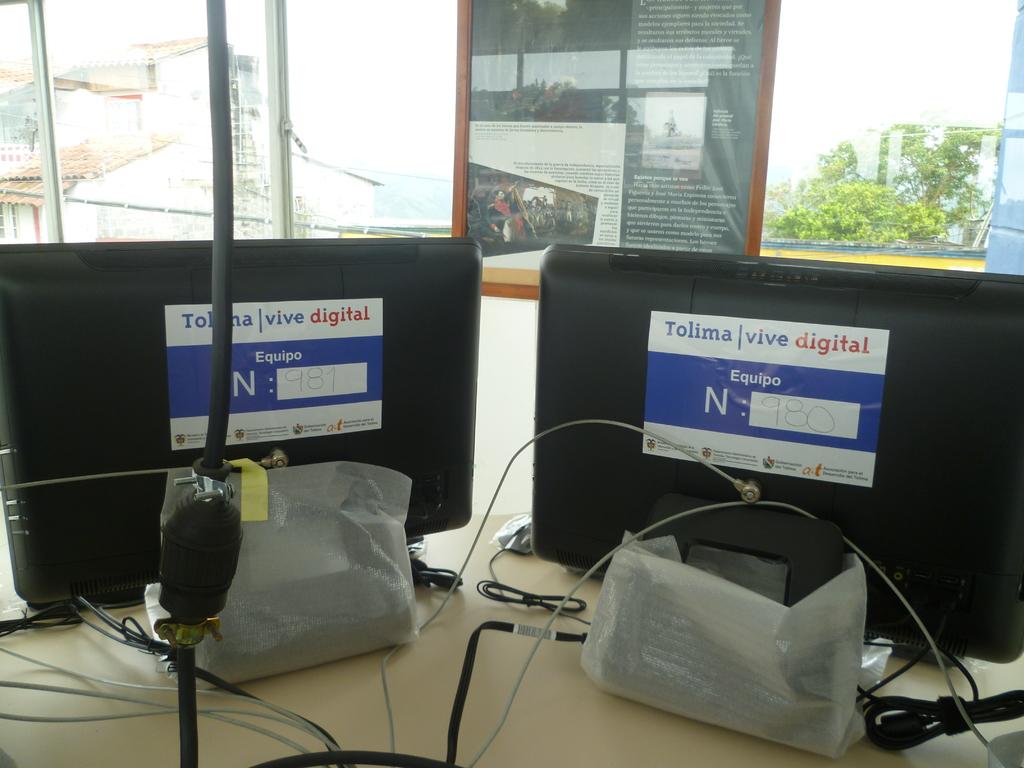What is the word in red?
Provide a short and direct response. Digital. What letter is large and white?
Give a very brief answer. N. 